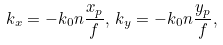<formula> <loc_0><loc_0><loc_500><loc_500>k _ { x } = - k _ { 0 } n \frac { x _ { p } } { f } , \, k _ { y } = - k _ { 0 } n \frac { y _ { p } } { f } , \,</formula> 